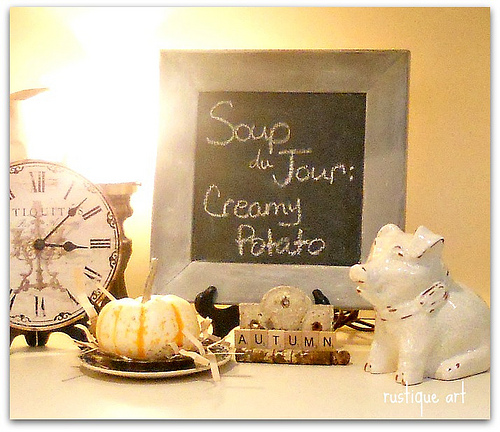<image>
Can you confirm if the sign is above the pig? Yes. The sign is positioned above the pig in the vertical space, higher up in the scene. 